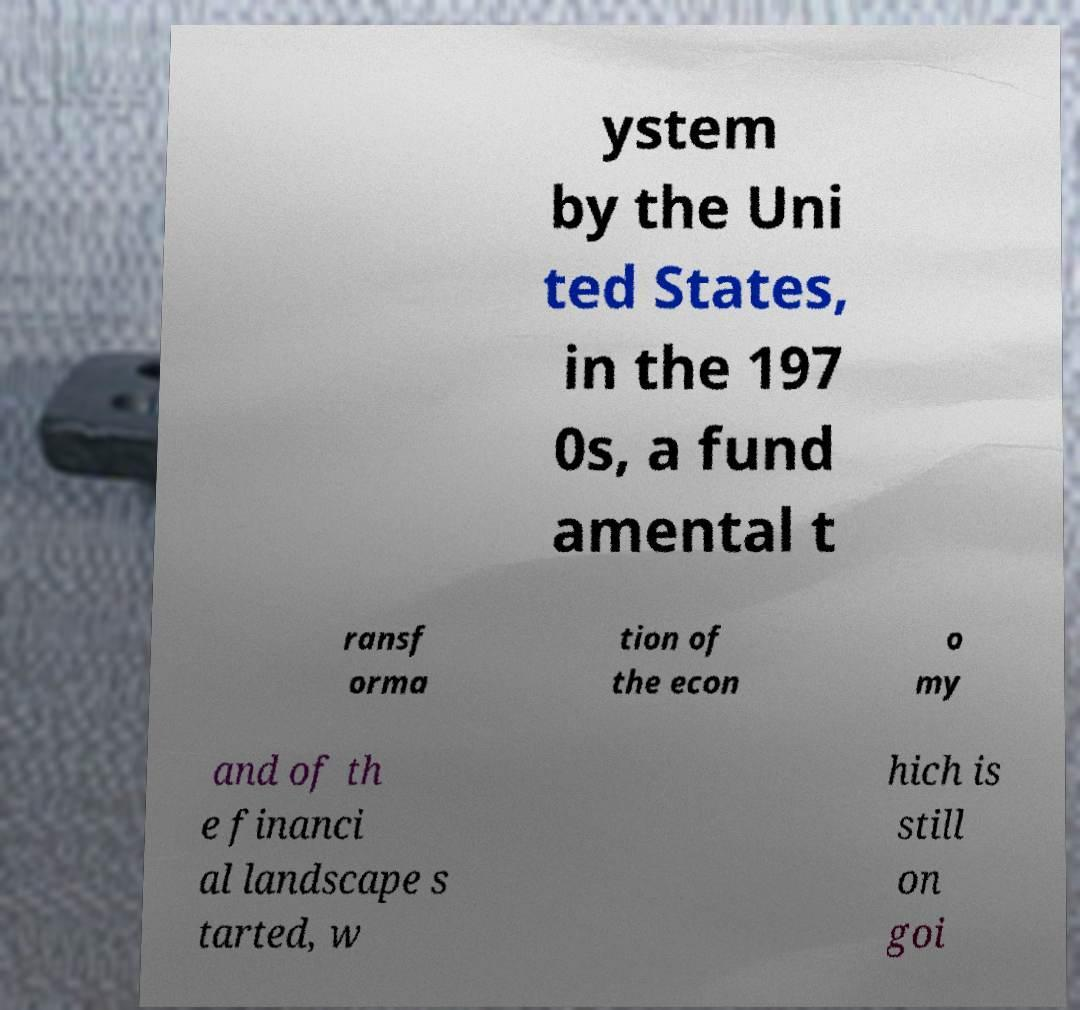Could you assist in decoding the text presented in this image and type it out clearly? ystem by the Uni ted States, in the 197 0s, a fund amental t ransf orma tion of the econ o my and of th e financi al landscape s tarted, w hich is still on goi 